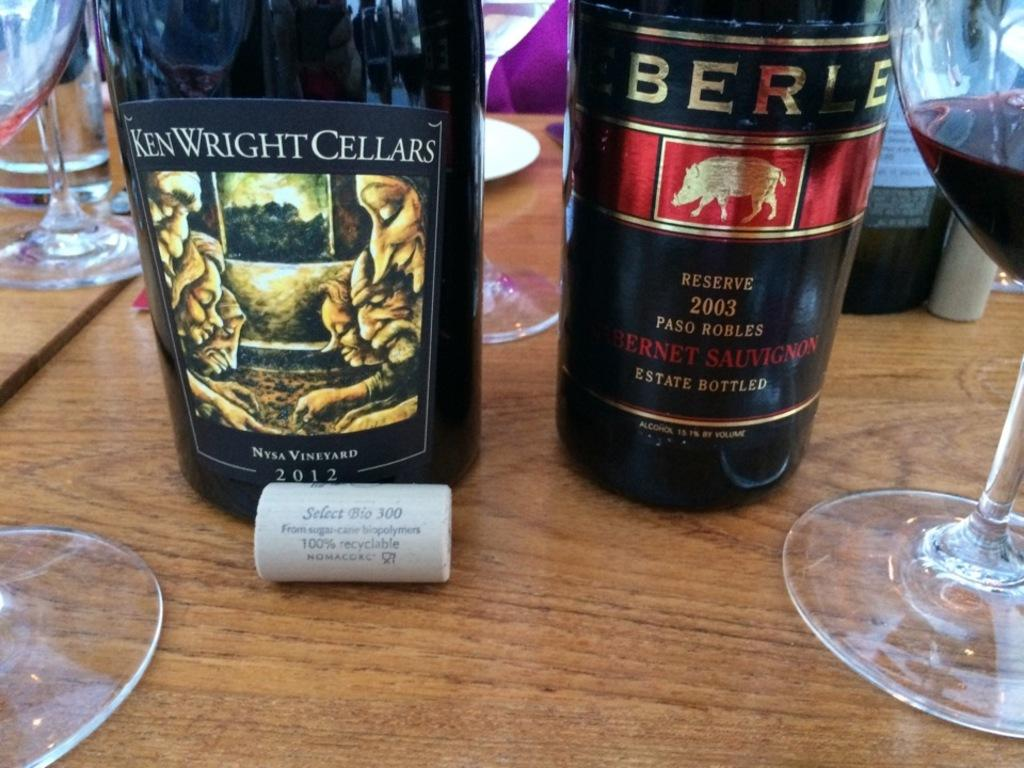<image>
Summarize the visual content of the image. Two bottles sit on the table one by Ken Wright Cellars. 